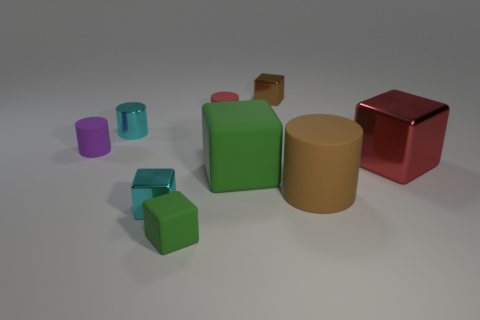Subtract all brown cubes. How many cubes are left? 4 Add 1 cyan things. How many objects exist? 10 Subtract all cyan cylinders. How many cylinders are left? 3 Subtract 0 gray cylinders. How many objects are left? 9 Subtract all cubes. How many objects are left? 4 Subtract 3 cubes. How many cubes are left? 2 Subtract all purple cubes. Subtract all yellow balls. How many cubes are left? 5 Subtract all red blocks. How many brown cylinders are left? 1 Subtract all big green blocks. Subtract all green blocks. How many objects are left? 6 Add 8 tiny green things. How many tiny green things are left? 9 